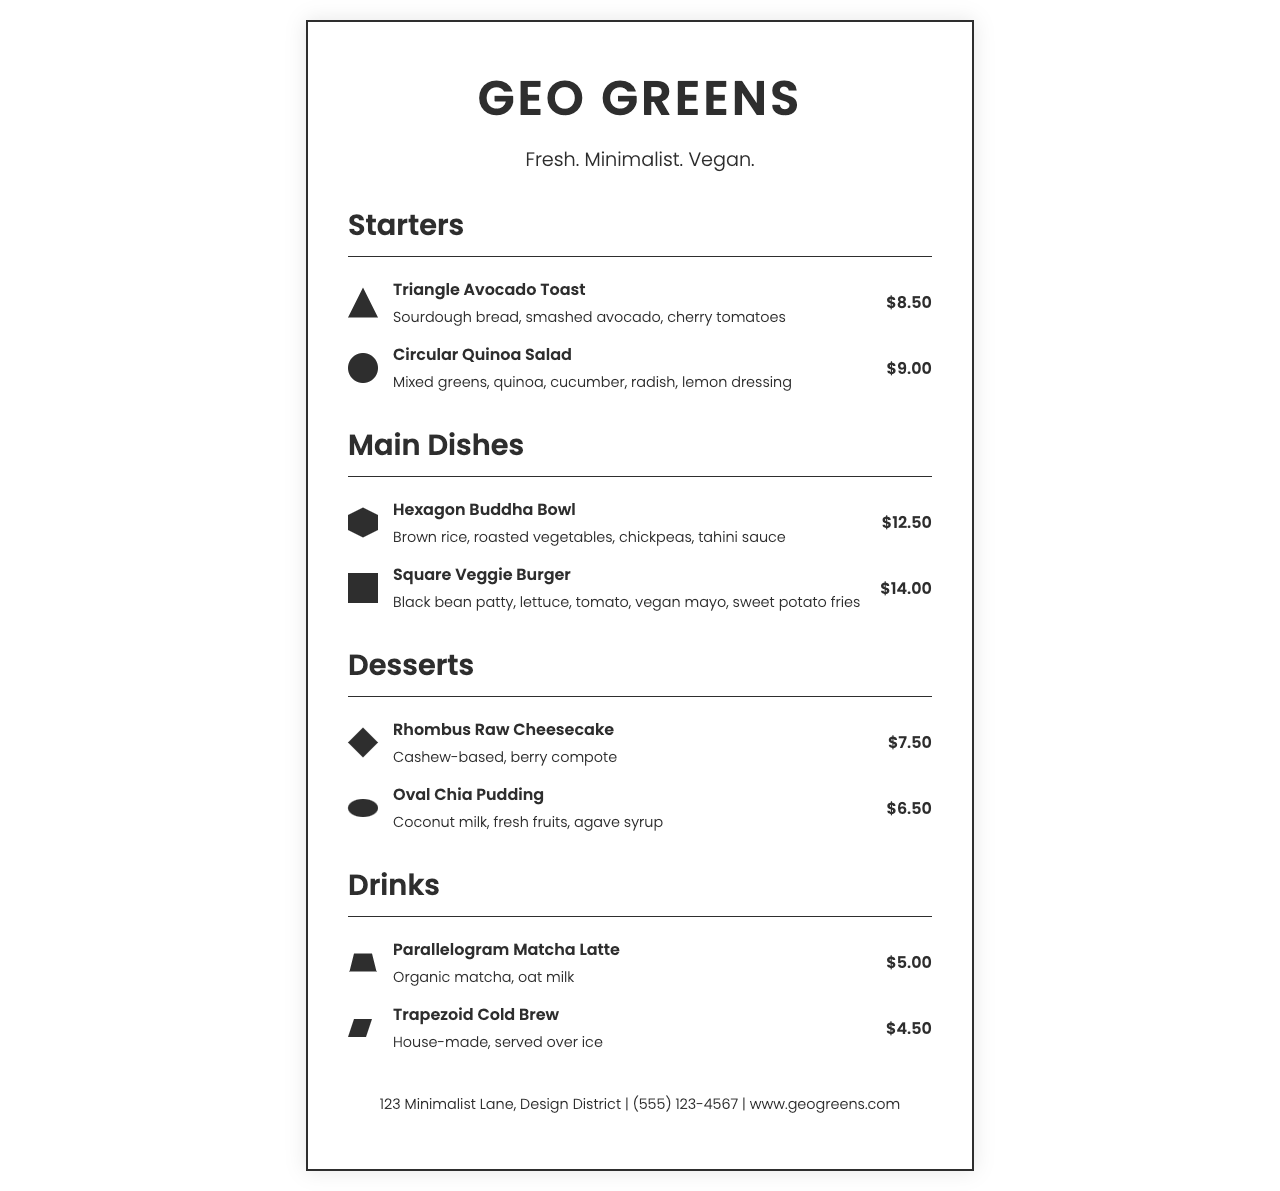what is the name of the cafe? The name of the cafe is prominently displayed at the top of the menu document.
Answer: GEO GREENS how much does the Square Veggie Burger cost? The price of the Square Veggie Burger is listed alongside its description.
Answer: $14.00 what is included in the Circular Quinoa Salad? The details of the Circular Quinoa Salad are provided in the description section.
Answer: Mixed greens, quinoa, cucumber, radish, lemon dressing how many sections are there in the menu? The document lists several types of dishes, indicating the sections present.
Answer: Four which dish has a rhombus shape in its name? The dishes often have geometric names related to their descriptions in the document.
Answer: Rhombus Raw Cheesecake what color scheme is used in the design? The overall appearance of the menu indicates a specific color palette utilized throughout.
Answer: Monochromatic how many drinks are listed on the menu? The document provides detailed items under the drinks section.
Answer: Two what is the tagline of the cafe? The tagline is a brief phrase that describes the essence of the cafe, found under the name.
Answer: Fresh. Minimalist. Vegan 